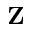Convert formula to latex. <formula><loc_0><loc_0><loc_500><loc_500>{ \mathbf Z }</formula> 